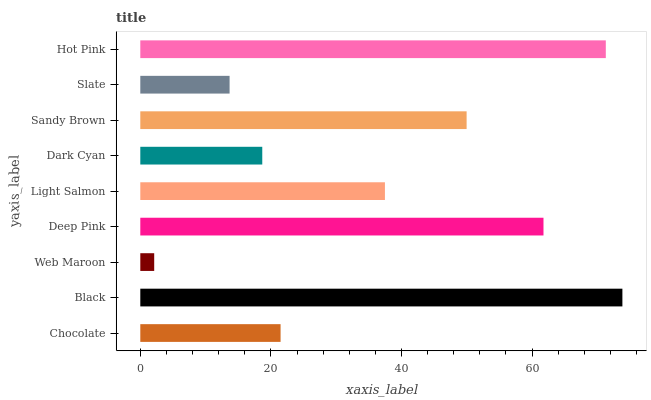Is Web Maroon the minimum?
Answer yes or no. Yes. Is Black the maximum?
Answer yes or no. Yes. Is Black the minimum?
Answer yes or no. No. Is Web Maroon the maximum?
Answer yes or no. No. Is Black greater than Web Maroon?
Answer yes or no. Yes. Is Web Maroon less than Black?
Answer yes or no. Yes. Is Web Maroon greater than Black?
Answer yes or no. No. Is Black less than Web Maroon?
Answer yes or no. No. Is Light Salmon the high median?
Answer yes or no. Yes. Is Light Salmon the low median?
Answer yes or no. Yes. Is Dark Cyan the high median?
Answer yes or no. No. Is Web Maroon the low median?
Answer yes or no. No. 